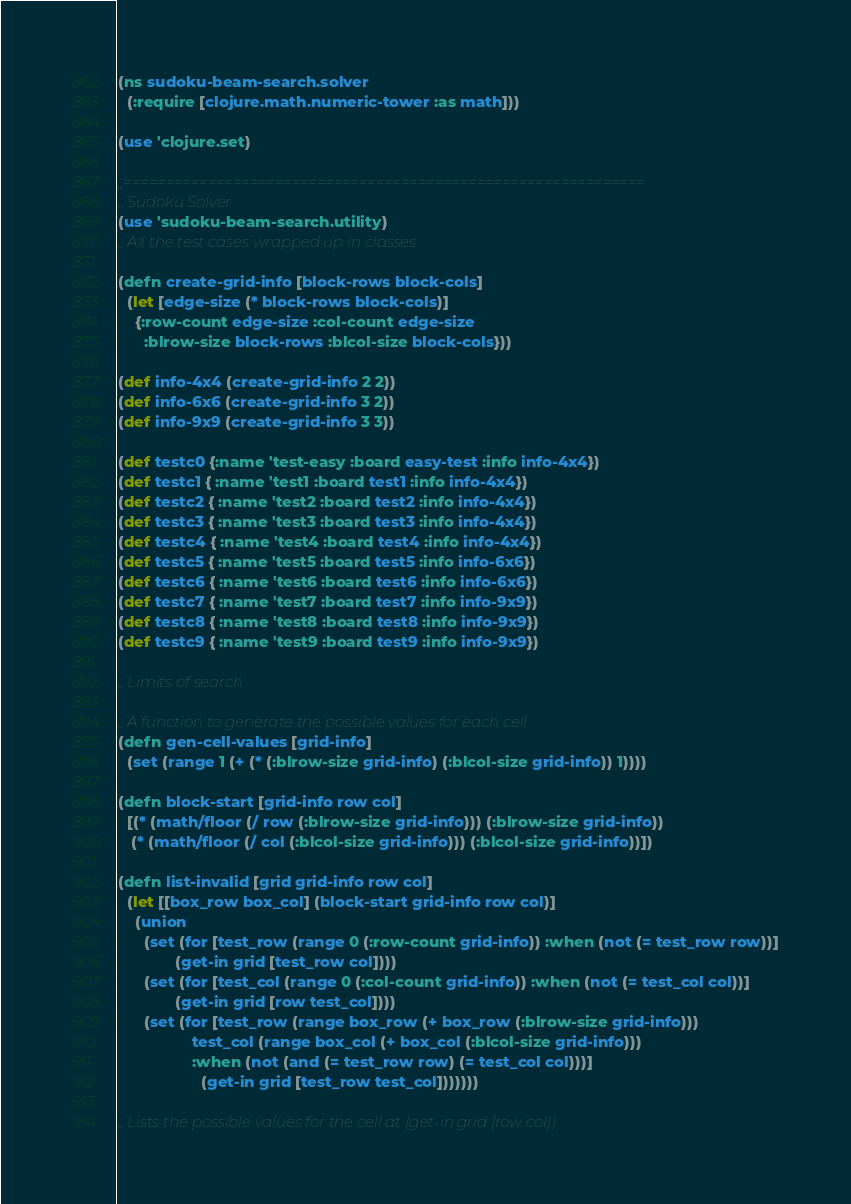<code> <loc_0><loc_0><loc_500><loc_500><_Clojure_>(ns sudoku-beam-search.solver
  (:require [clojure.math.numeric-tower :as math]))

(use 'clojure.set)

;;==============================================================
;; Sudoku Solver
(use 'sudoku-beam-search.utility)
;; All the test cases wrapped up in classes

(defn create-grid-info [block-rows block-cols]
  (let [edge-size (* block-rows block-cols)]
    {:row-count edge-size :col-count edge-size
      :blrow-size block-rows :blcol-size block-cols}))

(def info-4x4 (create-grid-info 2 2))
(def info-6x6 (create-grid-info 3 2))
(def info-9x9 (create-grid-info 3 3))

(def testc0 {:name 'test-easy :board easy-test :info info-4x4})
(def testc1 { :name 'test1 :board test1 :info info-4x4})
(def testc2 { :name 'test2 :board test2 :info info-4x4})
(def testc3 { :name 'test3 :board test3 :info info-4x4})
(def testc4 { :name 'test4 :board test4 :info info-4x4})
(def testc5 { :name 'test5 :board test5 :info info-6x6})
(def testc6 { :name 'test6 :board test6 :info info-6x6})
(def testc7 { :name 'test7 :board test7 :info info-9x9})
(def testc8 { :name 'test8 :board test8 :info info-9x9})
(def testc9 { :name 'test9 :board test9 :info info-9x9})

;; Limits of search

;; A function to generate the possible values for each cell
(defn gen-cell-values [grid-info]
  (set (range 1 (+ (* (:blrow-size grid-info) (:blcol-size grid-info)) 1))))

(defn block-start [grid-info row col]
  [(* (math/floor (/ row (:blrow-size grid-info))) (:blrow-size grid-info))
   (* (math/floor (/ col (:blcol-size grid-info))) (:blcol-size grid-info))])

(defn list-invalid [grid grid-info row col]
  (let [[box_row box_col] (block-start grid-info row col)]
    (union 
      (set (for [test_row (range 0 (:row-count grid-info)) :when (not (= test_row row))]
             (get-in grid [test_row col])))
      (set (for [test_col (range 0 (:col-count grid-info)) :when (not (= test_col col))]
             (get-in grid [row test_col])))
      (set (for [test_row (range box_row (+ box_row (:blrow-size grid-info)))
                 test_col (range box_col (+ box_col (:blcol-size grid-info)))
                 :when (not (and (= test_row row) (= test_col col)))]
                   (get-in grid [test_row test_col]))))))

;; Lists the possible values for the cell at (get-in grid [row col])</code> 